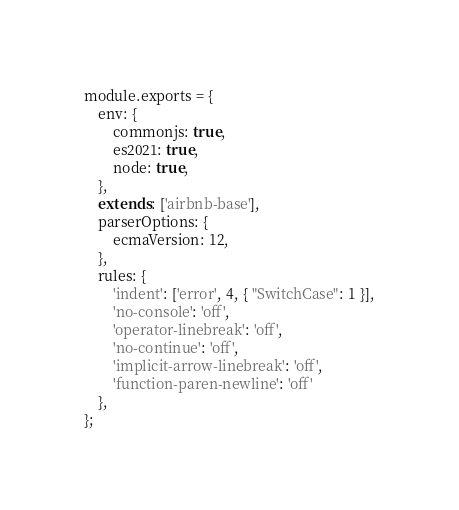Convert code to text. <code><loc_0><loc_0><loc_500><loc_500><_JavaScript_>module.exports = {
    env: {
        commonjs: true,
        es2021: true,
        node: true,
    },
    extends: ['airbnb-base'],
    parserOptions: {
        ecmaVersion: 12,
    },
    rules: {
        'indent': ['error', 4, { "SwitchCase": 1 }],
        'no-console': 'off',
        'operator-linebreak': 'off',
        'no-continue': 'off',
        'implicit-arrow-linebreak': 'off',
        'function-paren-newline': 'off'
    },
};
</code> 